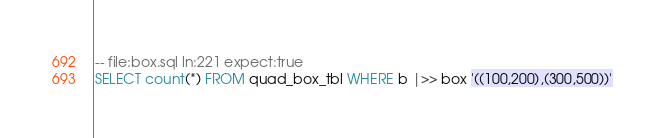Convert code to text. <code><loc_0><loc_0><loc_500><loc_500><_SQL_>-- file:box.sql ln:221 expect:true
SELECT count(*) FROM quad_box_tbl WHERE b |>> box '((100,200),(300,500))'
</code> 